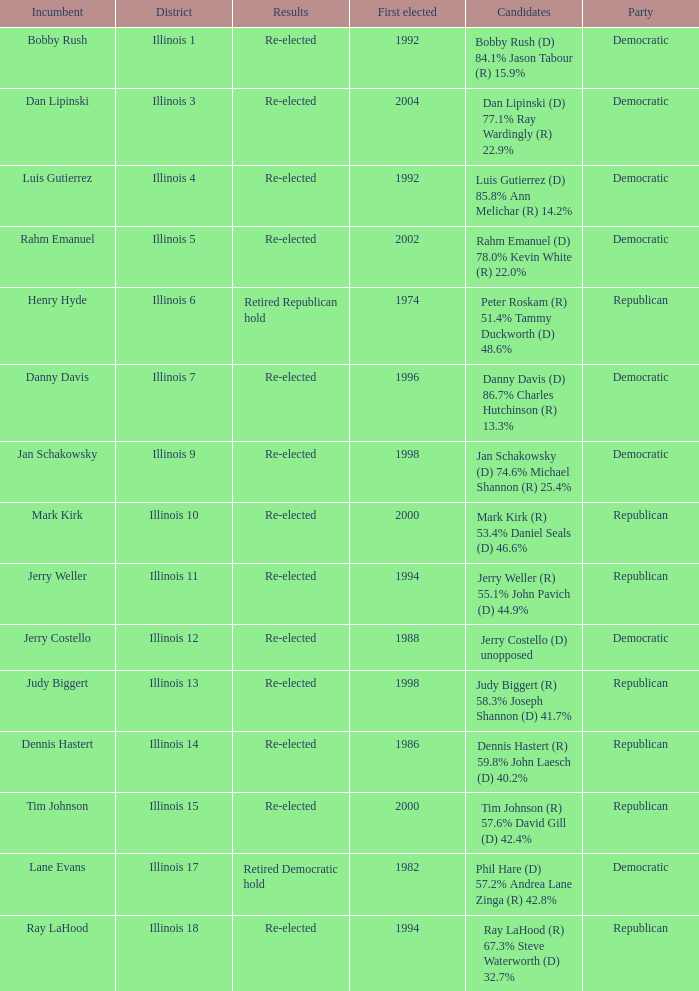Who were the candidates when the first elected was a republican in 1998?  Judy Biggert (R) 58.3% Joseph Shannon (D) 41.7%. 